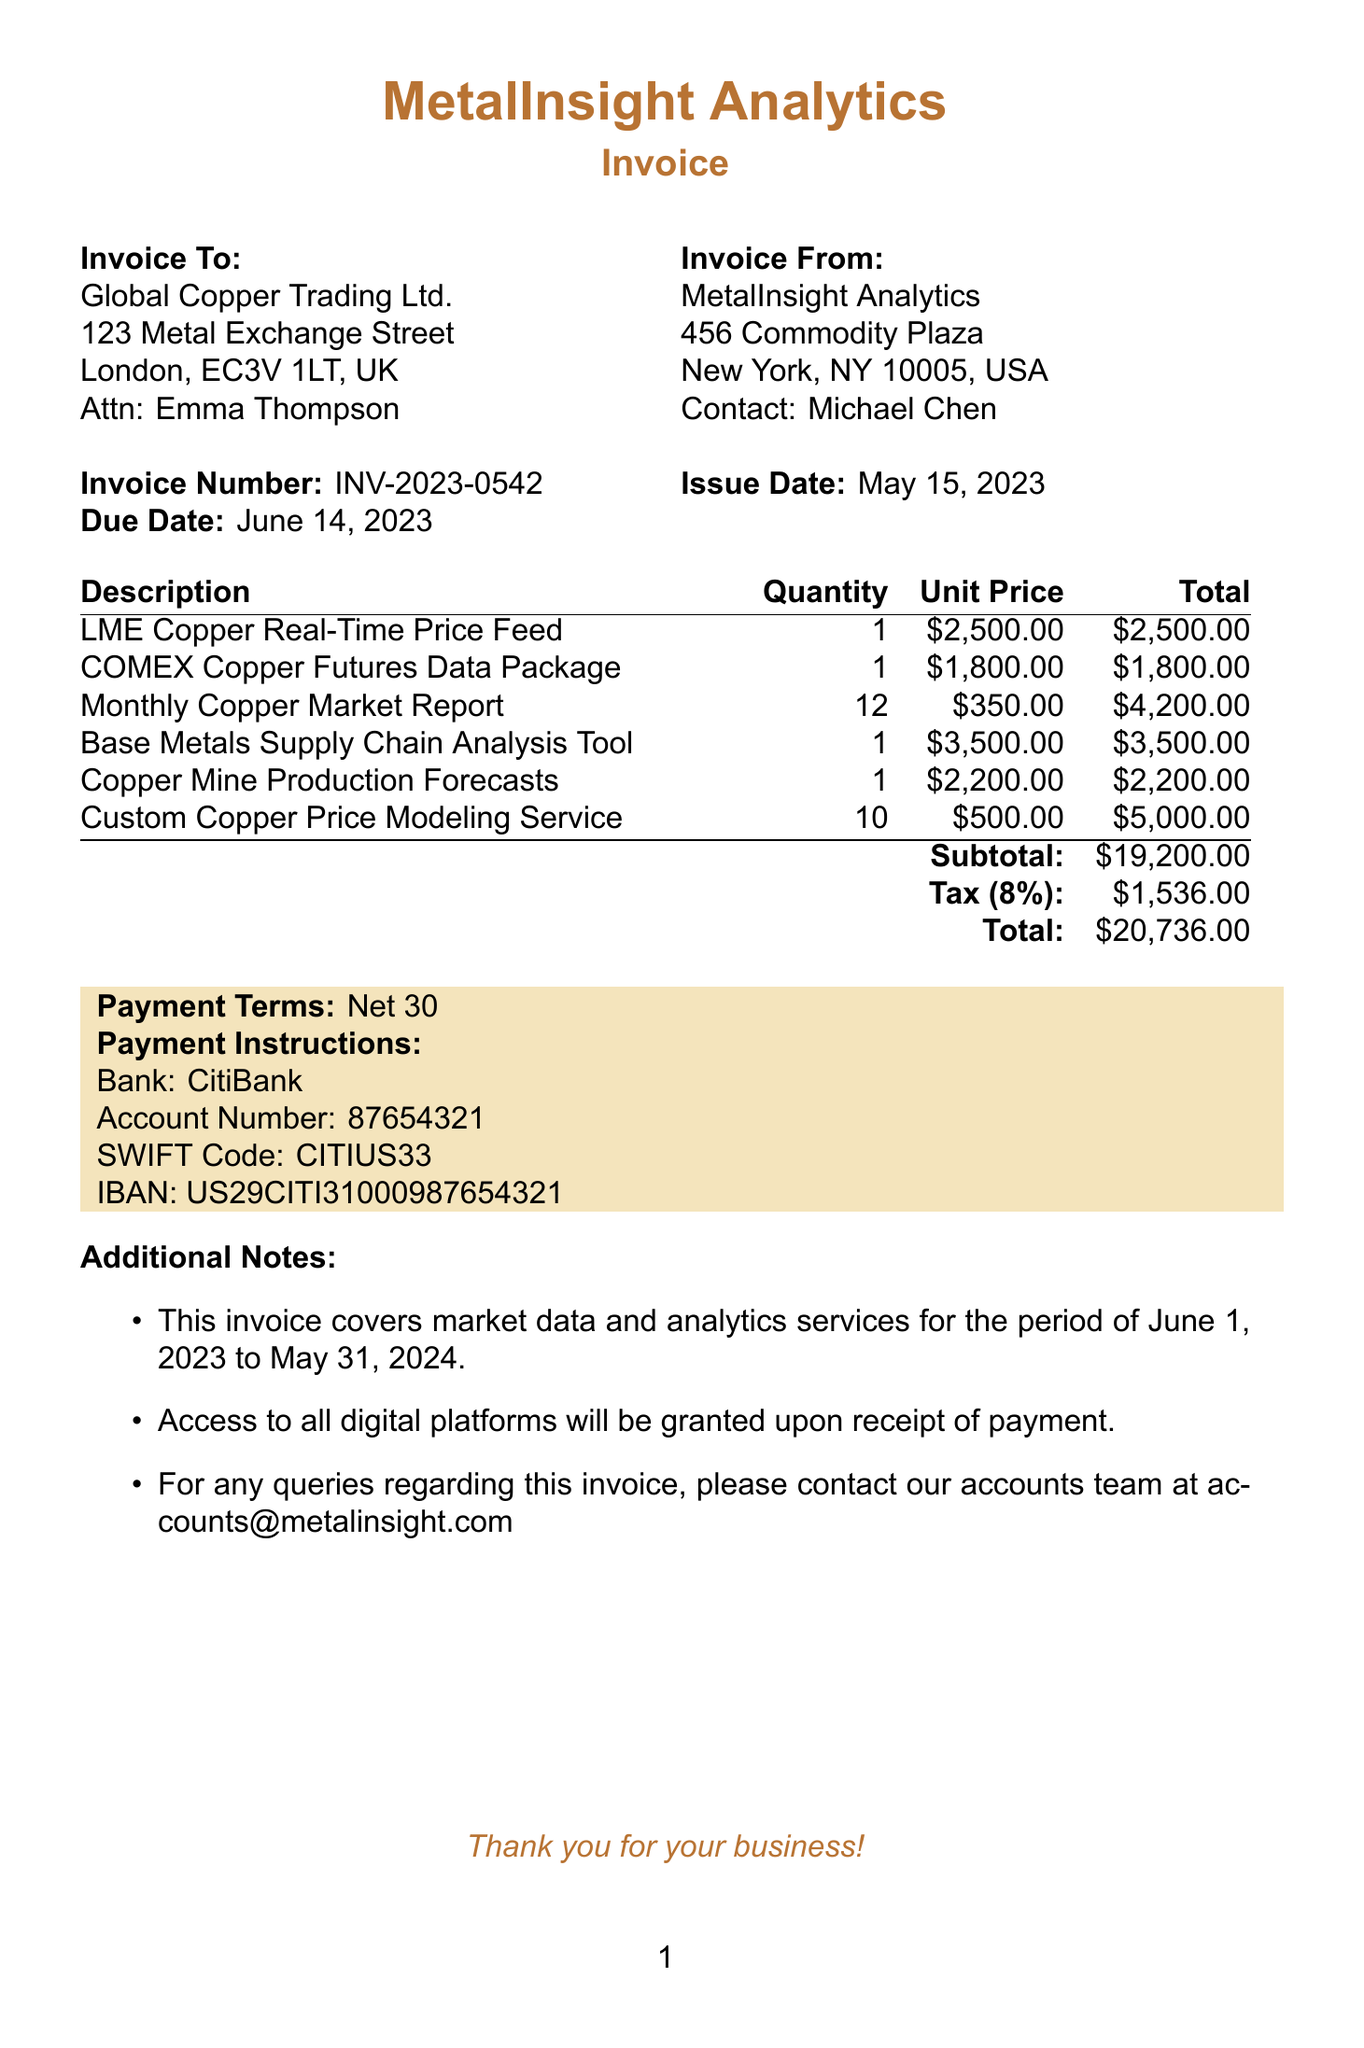What is the invoice number? The invoice number is stated prominently in the document and is labeled as "Invoice Number".
Answer: INV-2023-0542 What service has a unit price of 2500? The service with a unit price of 2500 is listed under "Description".
Answer: LME Copper Real-Time Price Feed What is the subtotal amount? The subtotal is calculated before tax and is labeled clearly in the invoice.
Answer: $19,200.00 Who is the contact person for the client? The contact person for the client is identified under "clientInfo".
Answer: Emma Thompson What is the total amount due? The total amount due is highlighted at the end of the invoice, which includes the subtotal and tax.
Answer: $20,736.00 What is the tax rate applied? The tax rate is explicitly stated in the invoice as a percentage beside the tax amount.
Answer: 8% What services are included in this invoice? The services listed are in the services section, detailing the specific analytics and data packages provided.
Answer: LME Copper Real-Time Price Feed, COMEX Copper Futures Data Package, Monthly Copper Market Report, Base Metals Supply Chain Analysis Tool, Copper Mine Production Forecasts, Custom Copper Price Modeling Service What payment terms are specified? The payment terms indicate when payment is due after the invoice date.
Answer: Net 30 For what period does this invoice cover market data services? The invoice notes the specific period during which the services are provided in the additional notes section.
Answer: June 1, 2023 to May 31, 2024 